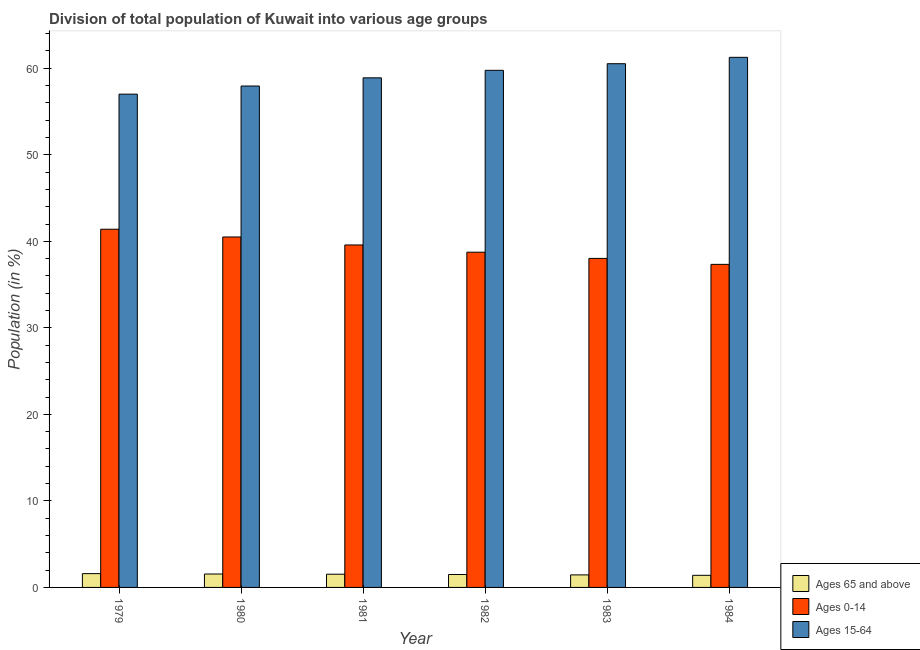How many different coloured bars are there?
Provide a succinct answer. 3. Are the number of bars per tick equal to the number of legend labels?
Give a very brief answer. Yes. Are the number of bars on each tick of the X-axis equal?
Your response must be concise. Yes. How many bars are there on the 4th tick from the right?
Your response must be concise. 3. What is the percentage of population within the age-group 0-14 in 1984?
Make the answer very short. 37.34. Across all years, what is the maximum percentage of population within the age-group of 65 and above?
Offer a very short reply. 1.59. Across all years, what is the minimum percentage of population within the age-group 0-14?
Provide a succinct answer. 37.34. In which year was the percentage of population within the age-group of 65 and above maximum?
Provide a succinct answer. 1979. In which year was the percentage of population within the age-group 15-64 minimum?
Offer a very short reply. 1979. What is the total percentage of population within the age-group 0-14 in the graph?
Keep it short and to the point. 235.58. What is the difference between the percentage of population within the age-group of 65 and above in 1980 and that in 1983?
Ensure brevity in your answer.  0.1. What is the difference between the percentage of population within the age-group 0-14 in 1980 and the percentage of population within the age-group 15-64 in 1984?
Your answer should be very brief. 3.16. What is the average percentage of population within the age-group 15-64 per year?
Your answer should be compact. 59.23. In how many years, is the percentage of population within the age-group 15-64 greater than 58 %?
Your response must be concise. 4. What is the ratio of the percentage of population within the age-group 15-64 in 1981 to that in 1982?
Your response must be concise. 0.99. Is the percentage of population within the age-group 15-64 in 1979 less than that in 1984?
Offer a very short reply. Yes. What is the difference between the highest and the second highest percentage of population within the age-group of 65 and above?
Provide a short and direct response. 0.04. What is the difference between the highest and the lowest percentage of population within the age-group 0-14?
Offer a very short reply. 4.06. In how many years, is the percentage of population within the age-group 15-64 greater than the average percentage of population within the age-group 15-64 taken over all years?
Your answer should be compact. 3. Is the sum of the percentage of population within the age-group 15-64 in 1982 and 1983 greater than the maximum percentage of population within the age-group of 65 and above across all years?
Provide a short and direct response. Yes. What does the 1st bar from the left in 1980 represents?
Keep it short and to the point. Ages 65 and above. What does the 3rd bar from the right in 1982 represents?
Offer a very short reply. Ages 65 and above. How many years are there in the graph?
Ensure brevity in your answer.  6. What is the difference between two consecutive major ticks on the Y-axis?
Give a very brief answer. 10. Does the graph contain any zero values?
Give a very brief answer. No. Does the graph contain grids?
Your answer should be very brief. No. Where does the legend appear in the graph?
Your answer should be compact. Bottom right. What is the title of the graph?
Your response must be concise. Division of total population of Kuwait into various age groups
. Does "Industrial Nitrous Oxide" appear as one of the legend labels in the graph?
Give a very brief answer. No. What is the label or title of the X-axis?
Make the answer very short. Year. What is the label or title of the Y-axis?
Make the answer very short. Population (in %). What is the Population (in %) of Ages 65 and above in 1979?
Provide a succinct answer. 1.59. What is the Population (in %) of Ages 0-14 in 1979?
Your response must be concise. 41.4. What is the Population (in %) in Ages 15-64 in 1979?
Provide a succinct answer. 57.01. What is the Population (in %) of Ages 65 and above in 1980?
Your response must be concise. 1.55. What is the Population (in %) of Ages 0-14 in 1980?
Your answer should be very brief. 40.5. What is the Population (in %) in Ages 15-64 in 1980?
Offer a terse response. 57.95. What is the Population (in %) in Ages 65 and above in 1981?
Keep it short and to the point. 1.53. What is the Population (in %) in Ages 0-14 in 1981?
Your answer should be compact. 39.58. What is the Population (in %) of Ages 15-64 in 1981?
Provide a succinct answer. 58.89. What is the Population (in %) in Ages 65 and above in 1982?
Offer a terse response. 1.49. What is the Population (in %) in Ages 0-14 in 1982?
Offer a terse response. 38.74. What is the Population (in %) of Ages 15-64 in 1982?
Offer a terse response. 59.76. What is the Population (in %) in Ages 65 and above in 1983?
Ensure brevity in your answer.  1.45. What is the Population (in %) in Ages 0-14 in 1983?
Your response must be concise. 38.03. What is the Population (in %) in Ages 15-64 in 1983?
Your response must be concise. 60.53. What is the Population (in %) of Ages 65 and above in 1984?
Provide a short and direct response. 1.4. What is the Population (in %) of Ages 0-14 in 1984?
Your answer should be very brief. 37.34. What is the Population (in %) of Ages 15-64 in 1984?
Provide a succinct answer. 61.26. Across all years, what is the maximum Population (in %) of Ages 65 and above?
Offer a terse response. 1.59. Across all years, what is the maximum Population (in %) of Ages 0-14?
Give a very brief answer. 41.4. Across all years, what is the maximum Population (in %) of Ages 15-64?
Provide a short and direct response. 61.26. Across all years, what is the minimum Population (in %) of Ages 65 and above?
Provide a succinct answer. 1.4. Across all years, what is the minimum Population (in %) of Ages 0-14?
Offer a very short reply. 37.34. Across all years, what is the minimum Population (in %) in Ages 15-64?
Make the answer very short. 57.01. What is the total Population (in %) of Ages 65 and above in the graph?
Your answer should be compact. 9.01. What is the total Population (in %) in Ages 0-14 in the graph?
Keep it short and to the point. 235.58. What is the total Population (in %) of Ages 15-64 in the graph?
Give a very brief answer. 355.4. What is the difference between the Population (in %) in Ages 65 and above in 1979 and that in 1980?
Ensure brevity in your answer.  0.04. What is the difference between the Population (in %) in Ages 0-14 in 1979 and that in 1980?
Provide a short and direct response. 0.9. What is the difference between the Population (in %) of Ages 15-64 in 1979 and that in 1980?
Give a very brief answer. -0.94. What is the difference between the Population (in %) in Ages 65 and above in 1979 and that in 1981?
Provide a succinct answer. 0.07. What is the difference between the Population (in %) in Ages 0-14 in 1979 and that in 1981?
Your answer should be very brief. 1.82. What is the difference between the Population (in %) of Ages 15-64 in 1979 and that in 1981?
Your response must be concise. -1.89. What is the difference between the Population (in %) of Ages 65 and above in 1979 and that in 1982?
Ensure brevity in your answer.  0.1. What is the difference between the Population (in %) in Ages 0-14 in 1979 and that in 1982?
Your answer should be compact. 2.65. What is the difference between the Population (in %) in Ages 15-64 in 1979 and that in 1982?
Your response must be concise. -2.76. What is the difference between the Population (in %) of Ages 65 and above in 1979 and that in 1983?
Ensure brevity in your answer.  0.15. What is the difference between the Population (in %) in Ages 0-14 in 1979 and that in 1983?
Give a very brief answer. 3.37. What is the difference between the Population (in %) of Ages 15-64 in 1979 and that in 1983?
Your answer should be compact. -3.52. What is the difference between the Population (in %) in Ages 65 and above in 1979 and that in 1984?
Offer a very short reply. 0.19. What is the difference between the Population (in %) of Ages 0-14 in 1979 and that in 1984?
Offer a very short reply. 4.06. What is the difference between the Population (in %) of Ages 15-64 in 1979 and that in 1984?
Provide a succinct answer. -4.26. What is the difference between the Population (in %) of Ages 65 and above in 1980 and that in 1981?
Your answer should be very brief. 0.02. What is the difference between the Population (in %) in Ages 0-14 in 1980 and that in 1981?
Your answer should be very brief. 0.92. What is the difference between the Population (in %) of Ages 15-64 in 1980 and that in 1981?
Give a very brief answer. -0.95. What is the difference between the Population (in %) of Ages 65 and above in 1980 and that in 1982?
Your answer should be very brief. 0.06. What is the difference between the Population (in %) of Ages 0-14 in 1980 and that in 1982?
Give a very brief answer. 1.76. What is the difference between the Population (in %) in Ages 15-64 in 1980 and that in 1982?
Provide a short and direct response. -1.82. What is the difference between the Population (in %) of Ages 65 and above in 1980 and that in 1983?
Your answer should be very brief. 0.1. What is the difference between the Population (in %) in Ages 0-14 in 1980 and that in 1983?
Your answer should be very brief. 2.48. What is the difference between the Population (in %) in Ages 15-64 in 1980 and that in 1983?
Offer a terse response. -2.58. What is the difference between the Population (in %) in Ages 65 and above in 1980 and that in 1984?
Provide a short and direct response. 0.15. What is the difference between the Population (in %) in Ages 0-14 in 1980 and that in 1984?
Ensure brevity in your answer.  3.16. What is the difference between the Population (in %) in Ages 15-64 in 1980 and that in 1984?
Provide a short and direct response. -3.32. What is the difference between the Population (in %) in Ages 65 and above in 1981 and that in 1982?
Provide a succinct answer. 0.03. What is the difference between the Population (in %) of Ages 0-14 in 1981 and that in 1982?
Offer a very short reply. 0.84. What is the difference between the Population (in %) of Ages 15-64 in 1981 and that in 1982?
Keep it short and to the point. -0.87. What is the difference between the Population (in %) of Ages 65 and above in 1981 and that in 1983?
Your answer should be compact. 0.08. What is the difference between the Population (in %) of Ages 0-14 in 1981 and that in 1983?
Offer a terse response. 1.55. What is the difference between the Population (in %) in Ages 15-64 in 1981 and that in 1983?
Make the answer very short. -1.63. What is the difference between the Population (in %) in Ages 65 and above in 1981 and that in 1984?
Give a very brief answer. 0.13. What is the difference between the Population (in %) in Ages 0-14 in 1981 and that in 1984?
Your answer should be compact. 2.24. What is the difference between the Population (in %) of Ages 15-64 in 1981 and that in 1984?
Your answer should be very brief. -2.37. What is the difference between the Population (in %) of Ages 65 and above in 1982 and that in 1983?
Your answer should be very brief. 0.05. What is the difference between the Population (in %) of Ages 0-14 in 1982 and that in 1983?
Give a very brief answer. 0.72. What is the difference between the Population (in %) of Ages 15-64 in 1982 and that in 1983?
Provide a short and direct response. -0.76. What is the difference between the Population (in %) in Ages 65 and above in 1982 and that in 1984?
Make the answer very short. 0.09. What is the difference between the Population (in %) in Ages 0-14 in 1982 and that in 1984?
Provide a succinct answer. 1.41. What is the difference between the Population (in %) of Ages 15-64 in 1982 and that in 1984?
Provide a short and direct response. -1.5. What is the difference between the Population (in %) of Ages 65 and above in 1983 and that in 1984?
Ensure brevity in your answer.  0.05. What is the difference between the Population (in %) of Ages 0-14 in 1983 and that in 1984?
Your answer should be very brief. 0.69. What is the difference between the Population (in %) of Ages 15-64 in 1983 and that in 1984?
Your answer should be very brief. -0.74. What is the difference between the Population (in %) of Ages 65 and above in 1979 and the Population (in %) of Ages 0-14 in 1980?
Ensure brevity in your answer.  -38.91. What is the difference between the Population (in %) in Ages 65 and above in 1979 and the Population (in %) in Ages 15-64 in 1980?
Give a very brief answer. -56.35. What is the difference between the Population (in %) of Ages 0-14 in 1979 and the Population (in %) of Ages 15-64 in 1980?
Your response must be concise. -16.55. What is the difference between the Population (in %) in Ages 65 and above in 1979 and the Population (in %) in Ages 0-14 in 1981?
Your answer should be very brief. -37.98. What is the difference between the Population (in %) of Ages 65 and above in 1979 and the Population (in %) of Ages 15-64 in 1981?
Make the answer very short. -57.3. What is the difference between the Population (in %) of Ages 0-14 in 1979 and the Population (in %) of Ages 15-64 in 1981?
Make the answer very short. -17.5. What is the difference between the Population (in %) of Ages 65 and above in 1979 and the Population (in %) of Ages 0-14 in 1982?
Your answer should be very brief. -37.15. What is the difference between the Population (in %) of Ages 65 and above in 1979 and the Population (in %) of Ages 15-64 in 1982?
Give a very brief answer. -58.17. What is the difference between the Population (in %) in Ages 0-14 in 1979 and the Population (in %) in Ages 15-64 in 1982?
Make the answer very short. -18.36. What is the difference between the Population (in %) of Ages 65 and above in 1979 and the Population (in %) of Ages 0-14 in 1983?
Keep it short and to the point. -36.43. What is the difference between the Population (in %) in Ages 65 and above in 1979 and the Population (in %) in Ages 15-64 in 1983?
Offer a terse response. -58.93. What is the difference between the Population (in %) in Ages 0-14 in 1979 and the Population (in %) in Ages 15-64 in 1983?
Your answer should be very brief. -19.13. What is the difference between the Population (in %) of Ages 65 and above in 1979 and the Population (in %) of Ages 0-14 in 1984?
Provide a short and direct response. -35.74. What is the difference between the Population (in %) in Ages 65 and above in 1979 and the Population (in %) in Ages 15-64 in 1984?
Give a very brief answer. -59.67. What is the difference between the Population (in %) of Ages 0-14 in 1979 and the Population (in %) of Ages 15-64 in 1984?
Provide a short and direct response. -19.87. What is the difference between the Population (in %) in Ages 65 and above in 1980 and the Population (in %) in Ages 0-14 in 1981?
Offer a very short reply. -38.03. What is the difference between the Population (in %) in Ages 65 and above in 1980 and the Population (in %) in Ages 15-64 in 1981?
Provide a succinct answer. -57.34. What is the difference between the Population (in %) in Ages 0-14 in 1980 and the Population (in %) in Ages 15-64 in 1981?
Provide a succinct answer. -18.39. What is the difference between the Population (in %) of Ages 65 and above in 1980 and the Population (in %) of Ages 0-14 in 1982?
Ensure brevity in your answer.  -37.19. What is the difference between the Population (in %) of Ages 65 and above in 1980 and the Population (in %) of Ages 15-64 in 1982?
Make the answer very short. -58.21. What is the difference between the Population (in %) in Ages 0-14 in 1980 and the Population (in %) in Ages 15-64 in 1982?
Offer a terse response. -19.26. What is the difference between the Population (in %) in Ages 65 and above in 1980 and the Population (in %) in Ages 0-14 in 1983?
Keep it short and to the point. -36.47. What is the difference between the Population (in %) in Ages 65 and above in 1980 and the Population (in %) in Ages 15-64 in 1983?
Your answer should be very brief. -58.98. What is the difference between the Population (in %) of Ages 0-14 in 1980 and the Population (in %) of Ages 15-64 in 1983?
Offer a terse response. -20.03. What is the difference between the Population (in %) of Ages 65 and above in 1980 and the Population (in %) of Ages 0-14 in 1984?
Keep it short and to the point. -35.79. What is the difference between the Population (in %) in Ages 65 and above in 1980 and the Population (in %) in Ages 15-64 in 1984?
Your answer should be compact. -59.71. What is the difference between the Population (in %) in Ages 0-14 in 1980 and the Population (in %) in Ages 15-64 in 1984?
Your answer should be compact. -20.76. What is the difference between the Population (in %) of Ages 65 and above in 1981 and the Population (in %) of Ages 0-14 in 1982?
Offer a very short reply. -37.22. What is the difference between the Population (in %) of Ages 65 and above in 1981 and the Population (in %) of Ages 15-64 in 1982?
Give a very brief answer. -58.24. What is the difference between the Population (in %) of Ages 0-14 in 1981 and the Population (in %) of Ages 15-64 in 1982?
Keep it short and to the point. -20.18. What is the difference between the Population (in %) in Ages 65 and above in 1981 and the Population (in %) in Ages 0-14 in 1983?
Give a very brief answer. -36.5. What is the difference between the Population (in %) in Ages 65 and above in 1981 and the Population (in %) in Ages 15-64 in 1983?
Your response must be concise. -59. What is the difference between the Population (in %) of Ages 0-14 in 1981 and the Population (in %) of Ages 15-64 in 1983?
Provide a succinct answer. -20.95. What is the difference between the Population (in %) of Ages 65 and above in 1981 and the Population (in %) of Ages 0-14 in 1984?
Your answer should be compact. -35.81. What is the difference between the Population (in %) of Ages 65 and above in 1981 and the Population (in %) of Ages 15-64 in 1984?
Your response must be concise. -59.74. What is the difference between the Population (in %) in Ages 0-14 in 1981 and the Population (in %) in Ages 15-64 in 1984?
Give a very brief answer. -21.68. What is the difference between the Population (in %) in Ages 65 and above in 1982 and the Population (in %) in Ages 0-14 in 1983?
Offer a very short reply. -36.53. What is the difference between the Population (in %) in Ages 65 and above in 1982 and the Population (in %) in Ages 15-64 in 1983?
Make the answer very short. -59.03. What is the difference between the Population (in %) of Ages 0-14 in 1982 and the Population (in %) of Ages 15-64 in 1983?
Make the answer very short. -21.78. What is the difference between the Population (in %) of Ages 65 and above in 1982 and the Population (in %) of Ages 0-14 in 1984?
Make the answer very short. -35.84. What is the difference between the Population (in %) of Ages 65 and above in 1982 and the Population (in %) of Ages 15-64 in 1984?
Make the answer very short. -59.77. What is the difference between the Population (in %) of Ages 0-14 in 1982 and the Population (in %) of Ages 15-64 in 1984?
Make the answer very short. -22.52. What is the difference between the Population (in %) of Ages 65 and above in 1983 and the Population (in %) of Ages 0-14 in 1984?
Offer a terse response. -35.89. What is the difference between the Population (in %) in Ages 65 and above in 1983 and the Population (in %) in Ages 15-64 in 1984?
Offer a very short reply. -59.82. What is the difference between the Population (in %) of Ages 0-14 in 1983 and the Population (in %) of Ages 15-64 in 1984?
Ensure brevity in your answer.  -23.24. What is the average Population (in %) in Ages 65 and above per year?
Provide a short and direct response. 1.5. What is the average Population (in %) of Ages 0-14 per year?
Offer a terse response. 39.26. What is the average Population (in %) in Ages 15-64 per year?
Offer a very short reply. 59.23. In the year 1979, what is the difference between the Population (in %) of Ages 65 and above and Population (in %) of Ages 0-14?
Offer a very short reply. -39.8. In the year 1979, what is the difference between the Population (in %) in Ages 65 and above and Population (in %) in Ages 15-64?
Offer a very short reply. -55.41. In the year 1979, what is the difference between the Population (in %) of Ages 0-14 and Population (in %) of Ages 15-64?
Your response must be concise. -15.61. In the year 1980, what is the difference between the Population (in %) in Ages 65 and above and Population (in %) in Ages 0-14?
Keep it short and to the point. -38.95. In the year 1980, what is the difference between the Population (in %) in Ages 65 and above and Population (in %) in Ages 15-64?
Your answer should be compact. -56.4. In the year 1980, what is the difference between the Population (in %) of Ages 0-14 and Population (in %) of Ages 15-64?
Your response must be concise. -17.45. In the year 1981, what is the difference between the Population (in %) in Ages 65 and above and Population (in %) in Ages 0-14?
Your response must be concise. -38.05. In the year 1981, what is the difference between the Population (in %) in Ages 65 and above and Population (in %) in Ages 15-64?
Your answer should be compact. -57.37. In the year 1981, what is the difference between the Population (in %) in Ages 0-14 and Population (in %) in Ages 15-64?
Ensure brevity in your answer.  -19.32. In the year 1982, what is the difference between the Population (in %) in Ages 65 and above and Population (in %) in Ages 0-14?
Provide a succinct answer. -37.25. In the year 1982, what is the difference between the Population (in %) of Ages 65 and above and Population (in %) of Ages 15-64?
Provide a short and direct response. -58.27. In the year 1982, what is the difference between the Population (in %) of Ages 0-14 and Population (in %) of Ages 15-64?
Ensure brevity in your answer.  -21.02. In the year 1983, what is the difference between the Population (in %) of Ages 65 and above and Population (in %) of Ages 0-14?
Keep it short and to the point. -36.58. In the year 1983, what is the difference between the Population (in %) in Ages 65 and above and Population (in %) in Ages 15-64?
Offer a very short reply. -59.08. In the year 1983, what is the difference between the Population (in %) of Ages 0-14 and Population (in %) of Ages 15-64?
Your response must be concise. -22.5. In the year 1984, what is the difference between the Population (in %) in Ages 65 and above and Population (in %) in Ages 0-14?
Give a very brief answer. -35.94. In the year 1984, what is the difference between the Population (in %) of Ages 65 and above and Population (in %) of Ages 15-64?
Your answer should be very brief. -59.86. In the year 1984, what is the difference between the Population (in %) of Ages 0-14 and Population (in %) of Ages 15-64?
Your answer should be compact. -23.93. What is the ratio of the Population (in %) in Ages 65 and above in 1979 to that in 1980?
Offer a very short reply. 1.03. What is the ratio of the Population (in %) in Ages 0-14 in 1979 to that in 1980?
Your response must be concise. 1.02. What is the ratio of the Population (in %) in Ages 15-64 in 1979 to that in 1980?
Offer a terse response. 0.98. What is the ratio of the Population (in %) of Ages 65 and above in 1979 to that in 1981?
Your answer should be compact. 1.04. What is the ratio of the Population (in %) in Ages 0-14 in 1979 to that in 1981?
Offer a terse response. 1.05. What is the ratio of the Population (in %) in Ages 15-64 in 1979 to that in 1981?
Offer a very short reply. 0.97. What is the ratio of the Population (in %) of Ages 65 and above in 1979 to that in 1982?
Give a very brief answer. 1.07. What is the ratio of the Population (in %) of Ages 0-14 in 1979 to that in 1982?
Ensure brevity in your answer.  1.07. What is the ratio of the Population (in %) in Ages 15-64 in 1979 to that in 1982?
Offer a terse response. 0.95. What is the ratio of the Population (in %) of Ages 65 and above in 1979 to that in 1983?
Your answer should be compact. 1.1. What is the ratio of the Population (in %) in Ages 0-14 in 1979 to that in 1983?
Offer a very short reply. 1.09. What is the ratio of the Population (in %) of Ages 15-64 in 1979 to that in 1983?
Offer a very short reply. 0.94. What is the ratio of the Population (in %) in Ages 65 and above in 1979 to that in 1984?
Give a very brief answer. 1.14. What is the ratio of the Population (in %) of Ages 0-14 in 1979 to that in 1984?
Offer a terse response. 1.11. What is the ratio of the Population (in %) of Ages 15-64 in 1979 to that in 1984?
Provide a succinct answer. 0.93. What is the ratio of the Population (in %) in Ages 65 and above in 1980 to that in 1981?
Ensure brevity in your answer.  1.02. What is the ratio of the Population (in %) in Ages 0-14 in 1980 to that in 1981?
Keep it short and to the point. 1.02. What is the ratio of the Population (in %) in Ages 15-64 in 1980 to that in 1981?
Your response must be concise. 0.98. What is the ratio of the Population (in %) of Ages 65 and above in 1980 to that in 1982?
Make the answer very short. 1.04. What is the ratio of the Population (in %) of Ages 0-14 in 1980 to that in 1982?
Keep it short and to the point. 1.05. What is the ratio of the Population (in %) in Ages 15-64 in 1980 to that in 1982?
Offer a terse response. 0.97. What is the ratio of the Population (in %) of Ages 65 and above in 1980 to that in 1983?
Give a very brief answer. 1.07. What is the ratio of the Population (in %) in Ages 0-14 in 1980 to that in 1983?
Offer a terse response. 1.07. What is the ratio of the Population (in %) of Ages 15-64 in 1980 to that in 1983?
Provide a short and direct response. 0.96. What is the ratio of the Population (in %) in Ages 65 and above in 1980 to that in 1984?
Your answer should be very brief. 1.11. What is the ratio of the Population (in %) of Ages 0-14 in 1980 to that in 1984?
Ensure brevity in your answer.  1.08. What is the ratio of the Population (in %) in Ages 15-64 in 1980 to that in 1984?
Provide a short and direct response. 0.95. What is the ratio of the Population (in %) of Ages 65 and above in 1981 to that in 1982?
Make the answer very short. 1.02. What is the ratio of the Population (in %) of Ages 0-14 in 1981 to that in 1982?
Keep it short and to the point. 1.02. What is the ratio of the Population (in %) of Ages 15-64 in 1981 to that in 1982?
Give a very brief answer. 0.99. What is the ratio of the Population (in %) of Ages 65 and above in 1981 to that in 1983?
Provide a succinct answer. 1.05. What is the ratio of the Population (in %) in Ages 0-14 in 1981 to that in 1983?
Give a very brief answer. 1.04. What is the ratio of the Population (in %) of Ages 15-64 in 1981 to that in 1983?
Offer a very short reply. 0.97. What is the ratio of the Population (in %) of Ages 65 and above in 1981 to that in 1984?
Your answer should be compact. 1.09. What is the ratio of the Population (in %) of Ages 0-14 in 1981 to that in 1984?
Provide a short and direct response. 1.06. What is the ratio of the Population (in %) of Ages 15-64 in 1981 to that in 1984?
Make the answer very short. 0.96. What is the ratio of the Population (in %) in Ages 65 and above in 1982 to that in 1983?
Make the answer very short. 1.03. What is the ratio of the Population (in %) in Ages 0-14 in 1982 to that in 1983?
Ensure brevity in your answer.  1.02. What is the ratio of the Population (in %) of Ages 15-64 in 1982 to that in 1983?
Your response must be concise. 0.99. What is the ratio of the Population (in %) in Ages 65 and above in 1982 to that in 1984?
Offer a very short reply. 1.07. What is the ratio of the Population (in %) of Ages 0-14 in 1982 to that in 1984?
Ensure brevity in your answer.  1.04. What is the ratio of the Population (in %) of Ages 15-64 in 1982 to that in 1984?
Ensure brevity in your answer.  0.98. What is the ratio of the Population (in %) in Ages 65 and above in 1983 to that in 1984?
Offer a terse response. 1.03. What is the ratio of the Population (in %) of Ages 0-14 in 1983 to that in 1984?
Your answer should be very brief. 1.02. What is the ratio of the Population (in %) of Ages 15-64 in 1983 to that in 1984?
Provide a short and direct response. 0.99. What is the difference between the highest and the second highest Population (in %) of Ages 65 and above?
Your response must be concise. 0.04. What is the difference between the highest and the second highest Population (in %) in Ages 0-14?
Provide a short and direct response. 0.9. What is the difference between the highest and the second highest Population (in %) of Ages 15-64?
Keep it short and to the point. 0.74. What is the difference between the highest and the lowest Population (in %) of Ages 65 and above?
Keep it short and to the point. 0.19. What is the difference between the highest and the lowest Population (in %) of Ages 0-14?
Your answer should be very brief. 4.06. What is the difference between the highest and the lowest Population (in %) in Ages 15-64?
Offer a very short reply. 4.26. 